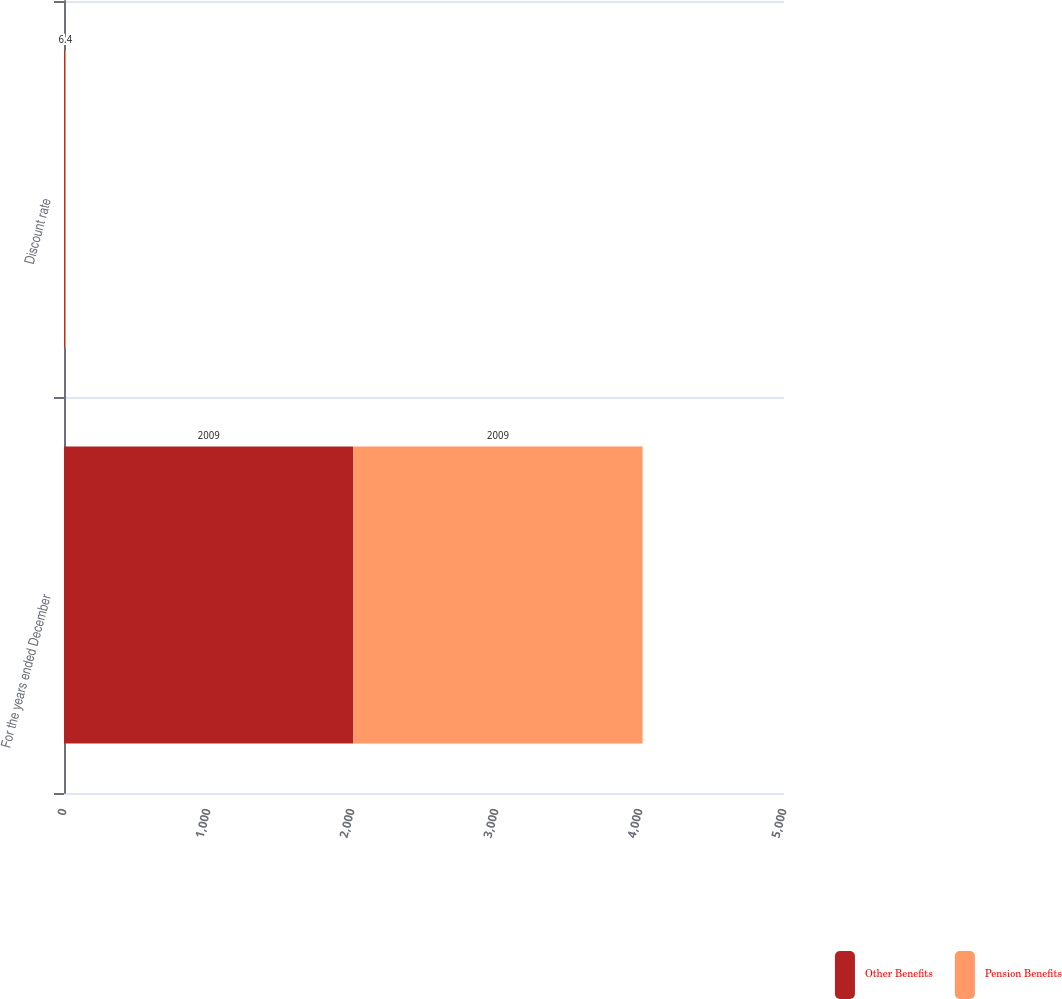<chart> <loc_0><loc_0><loc_500><loc_500><stacked_bar_chart><ecel><fcel>For the years ended December<fcel>Discount rate<nl><fcel>Other Benefits<fcel>2009<fcel>6.4<nl><fcel>Pension Benefits<fcel>2009<fcel>6.4<nl></chart> 